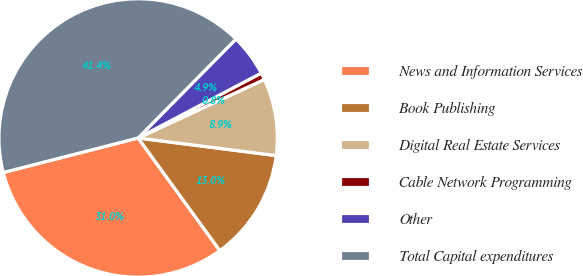Convert chart. <chart><loc_0><loc_0><loc_500><loc_500><pie_chart><fcel>News and Information Services<fcel>Book Publishing<fcel>Digital Real Estate Services<fcel>Cable Network Programming<fcel>Other<fcel>Total Capital expenditures<nl><fcel>31.0%<fcel>12.99%<fcel>8.93%<fcel>0.81%<fcel>4.87%<fcel>41.41%<nl></chart> 